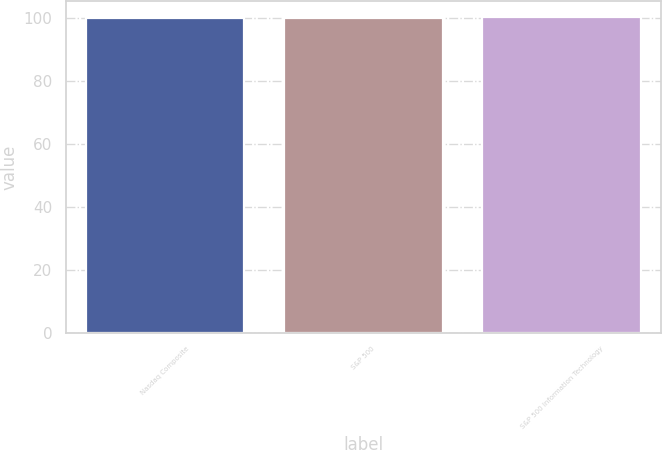Convert chart. <chart><loc_0><loc_0><loc_500><loc_500><bar_chart><fcel>Nasdaq Composite<fcel>S&P 500<fcel>S&P 500 Information Technology<nl><fcel>100<fcel>100.1<fcel>100.2<nl></chart> 